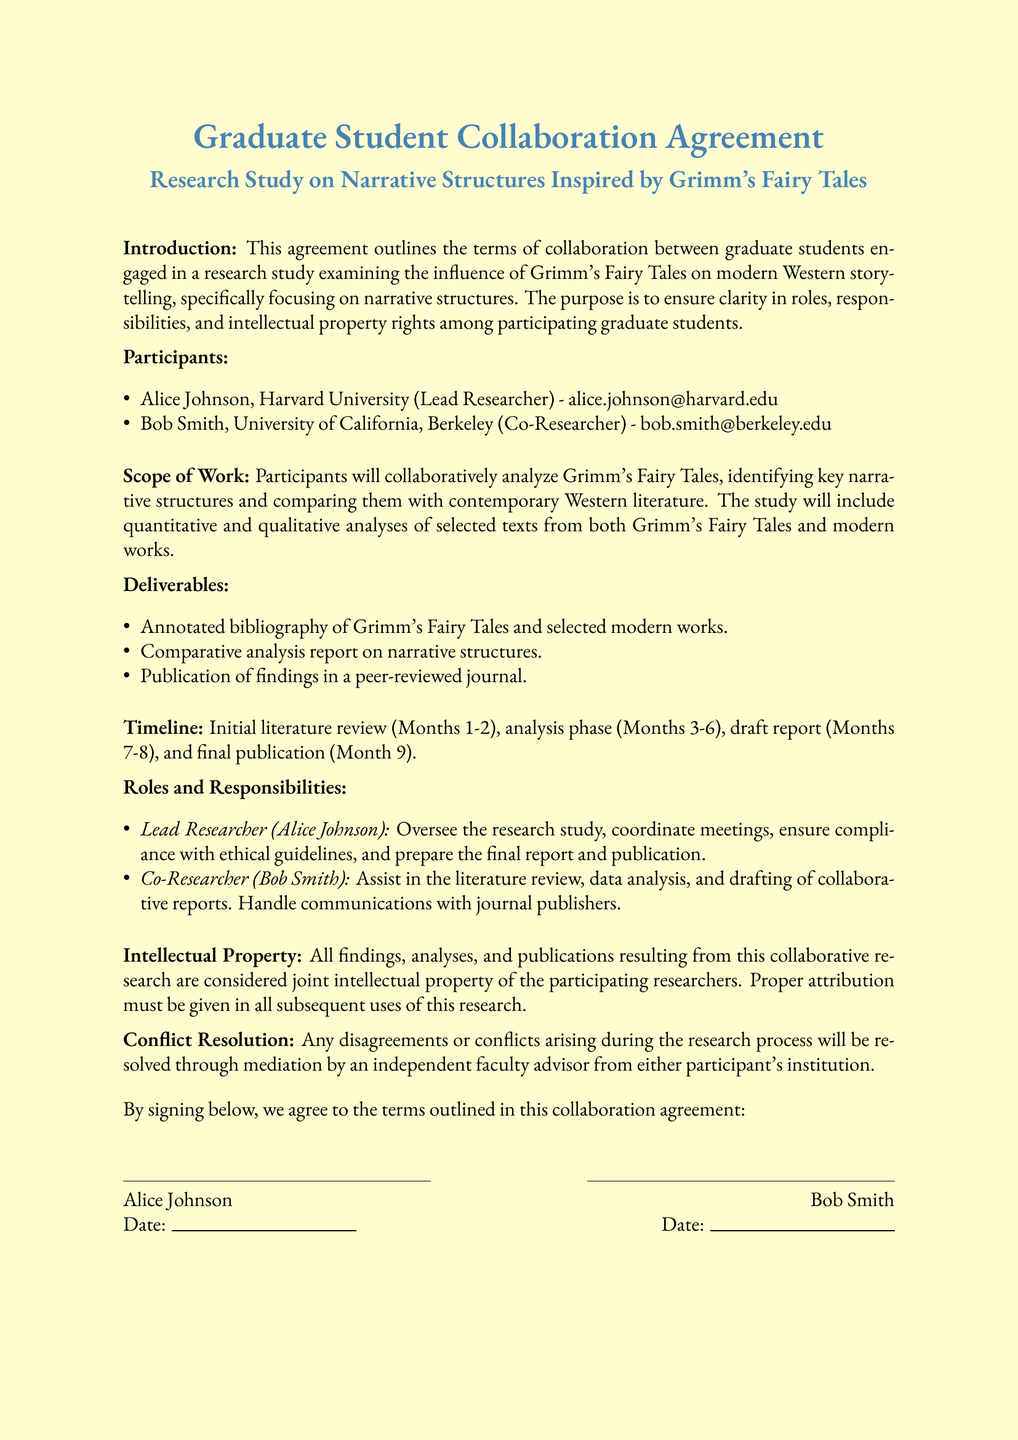What is the main purpose of the agreement? The purpose is to ensure clarity in roles, responsibilities, and intellectual property rights among participating graduate students.
Answer: Ensure clarity in roles, responsibilities, and intellectual property rights Who is the lead researcher? The document lists Alice Johnson as the Lead Researcher.
Answer: Alice Johnson What university does the co-researcher attend? The document states Bob Smith is from the University of California, Berkeley.
Answer: University of California, Berkeley How long is the analysis phase scheduled to last? The analysis phase is scheduled for Months 3-6, which totals to 4 months.
Answer: 4 months What is one deliverable of the study? The document mentions an annotated bibliography among the deliverables.
Answer: Annotated bibliography What are the dates of the initial literature review? The initial literature review takes place in Months 1-2, which is a span of two months.
Answer: Months 1-2 What type of resolution method is specified for conflicts? The agreement states that conflicts will be resolved through mediation.
Answer: Mediation How many participants are listed in the agreement? The document lists two participants: Alice Johnson and Bob Smith.
Answer: Two participants What color is the parchment background of the document? The document specifies the background color as "grimmparchment."
Answer: grimmparchment What is the publication requirement after the completion of the research? The findings must be published in a peer-reviewed journal.
Answer: Published in a peer-reviewed journal 